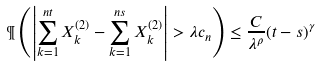<formula> <loc_0><loc_0><loc_500><loc_500>\P \left ( \left | \sum _ { k = 1 } ^ { n t } X _ { k } ^ { ( 2 ) } - \sum _ { k = 1 } ^ { n s } X _ { k } ^ { ( 2 ) } \right | > \lambda c _ { n } \right ) \leq \frac { C } { \lambda ^ { \rho } } ( t - s ) ^ { \gamma }</formula> 